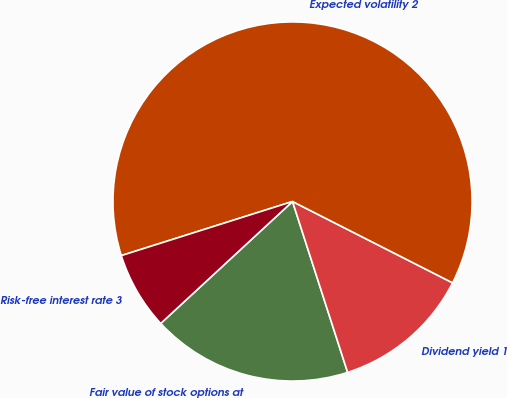Convert chart. <chart><loc_0><loc_0><loc_500><loc_500><pie_chart><fcel>Fair value of stock options at<fcel>Dividend yield 1<fcel>Expected volatility 2<fcel>Risk-free interest rate 3<nl><fcel>18.08%<fcel>12.55%<fcel>62.35%<fcel>7.01%<nl></chart> 